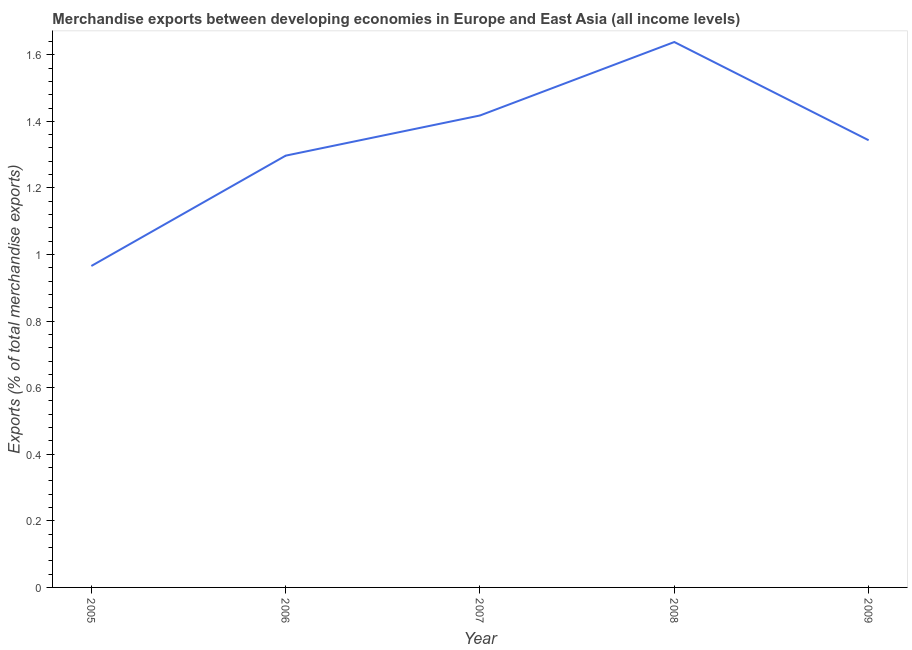What is the merchandise exports in 2007?
Provide a short and direct response. 1.42. Across all years, what is the maximum merchandise exports?
Your answer should be compact. 1.64. Across all years, what is the minimum merchandise exports?
Offer a very short reply. 0.97. In which year was the merchandise exports maximum?
Your answer should be compact. 2008. What is the sum of the merchandise exports?
Provide a short and direct response. 6.66. What is the difference between the merchandise exports in 2006 and 2007?
Your answer should be very brief. -0.12. What is the average merchandise exports per year?
Keep it short and to the point. 1.33. What is the median merchandise exports?
Give a very brief answer. 1.34. Do a majority of the years between 2006 and 2008 (inclusive) have merchandise exports greater than 0.48000000000000004 %?
Ensure brevity in your answer.  Yes. What is the ratio of the merchandise exports in 2006 to that in 2009?
Your answer should be very brief. 0.97. Is the merchandise exports in 2007 less than that in 2009?
Your answer should be compact. No. What is the difference between the highest and the second highest merchandise exports?
Offer a very short reply. 0.22. Is the sum of the merchandise exports in 2005 and 2008 greater than the maximum merchandise exports across all years?
Offer a terse response. Yes. What is the difference between the highest and the lowest merchandise exports?
Provide a short and direct response. 0.67. How many years are there in the graph?
Make the answer very short. 5. Does the graph contain any zero values?
Your answer should be compact. No. What is the title of the graph?
Your answer should be very brief. Merchandise exports between developing economies in Europe and East Asia (all income levels). What is the label or title of the Y-axis?
Keep it short and to the point. Exports (% of total merchandise exports). What is the Exports (% of total merchandise exports) of 2005?
Give a very brief answer. 0.97. What is the Exports (% of total merchandise exports) of 2006?
Offer a very short reply. 1.3. What is the Exports (% of total merchandise exports) of 2007?
Provide a short and direct response. 1.42. What is the Exports (% of total merchandise exports) in 2008?
Ensure brevity in your answer.  1.64. What is the Exports (% of total merchandise exports) in 2009?
Offer a terse response. 1.34. What is the difference between the Exports (% of total merchandise exports) in 2005 and 2006?
Your response must be concise. -0.33. What is the difference between the Exports (% of total merchandise exports) in 2005 and 2007?
Your response must be concise. -0.45. What is the difference between the Exports (% of total merchandise exports) in 2005 and 2008?
Your response must be concise. -0.67. What is the difference between the Exports (% of total merchandise exports) in 2005 and 2009?
Offer a terse response. -0.38. What is the difference between the Exports (% of total merchandise exports) in 2006 and 2007?
Provide a short and direct response. -0.12. What is the difference between the Exports (% of total merchandise exports) in 2006 and 2008?
Ensure brevity in your answer.  -0.34. What is the difference between the Exports (% of total merchandise exports) in 2006 and 2009?
Give a very brief answer. -0.05. What is the difference between the Exports (% of total merchandise exports) in 2007 and 2008?
Your answer should be compact. -0.22. What is the difference between the Exports (% of total merchandise exports) in 2007 and 2009?
Give a very brief answer. 0.07. What is the difference between the Exports (% of total merchandise exports) in 2008 and 2009?
Provide a succinct answer. 0.3. What is the ratio of the Exports (% of total merchandise exports) in 2005 to that in 2006?
Make the answer very short. 0.74. What is the ratio of the Exports (% of total merchandise exports) in 2005 to that in 2007?
Make the answer very short. 0.68. What is the ratio of the Exports (% of total merchandise exports) in 2005 to that in 2008?
Keep it short and to the point. 0.59. What is the ratio of the Exports (% of total merchandise exports) in 2005 to that in 2009?
Your answer should be compact. 0.72. What is the ratio of the Exports (% of total merchandise exports) in 2006 to that in 2007?
Your answer should be compact. 0.92. What is the ratio of the Exports (% of total merchandise exports) in 2006 to that in 2008?
Make the answer very short. 0.79. What is the ratio of the Exports (% of total merchandise exports) in 2006 to that in 2009?
Your answer should be compact. 0.97. What is the ratio of the Exports (% of total merchandise exports) in 2007 to that in 2008?
Keep it short and to the point. 0.86. What is the ratio of the Exports (% of total merchandise exports) in 2007 to that in 2009?
Provide a short and direct response. 1.05. What is the ratio of the Exports (% of total merchandise exports) in 2008 to that in 2009?
Provide a succinct answer. 1.22. 